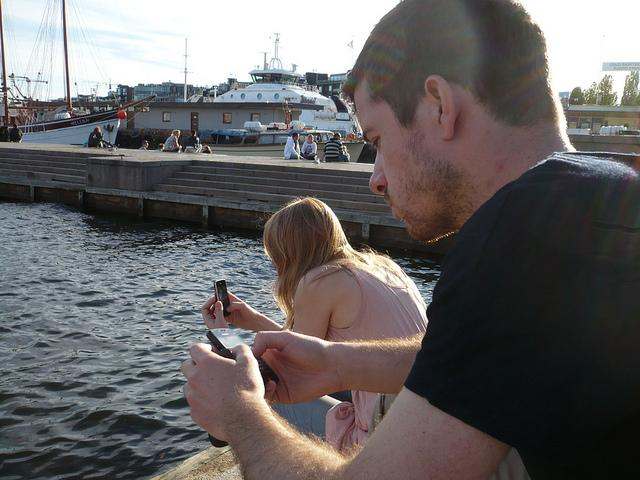If the man threw his phone 2 meters forward where would it land?

Choices:
A) in water
B) on boat
C) in grass
D) on woman in water 